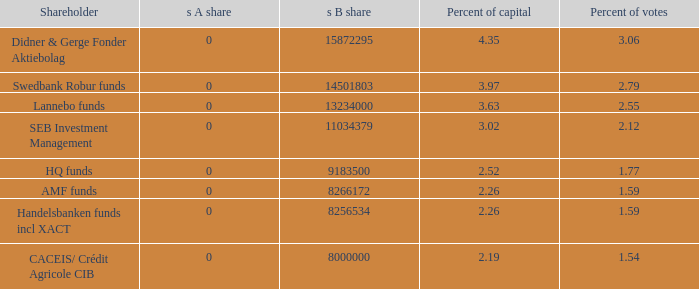What shareholder has 3.63 percent of capital?  Lannebo funds. I'm looking to parse the entire table for insights. Could you assist me with that? {'header': ['Shareholder', 's A share', 's B share', 'Percent of capital', 'Percent of votes'], 'rows': [['Didner & Gerge Fonder Aktiebolag', '0', '15872295', '4.35', '3.06'], ['Swedbank Robur funds', '0', '14501803', '3.97', '2.79'], ['Lannebo funds', '0', '13234000', '3.63', '2.55'], ['SEB Investment Management', '0', '11034379', '3.02', '2.12'], ['HQ funds', '0', '9183500', '2.52', '1.77'], ['AMF funds', '0', '8266172', '2.26', '1.59'], ['Handelsbanken funds incl XACT', '0', '8256534', '2.26', '1.59'], ['CACEIS/ Crédit Agricole CIB', '0', '8000000', '2.19', '1.54']]} 